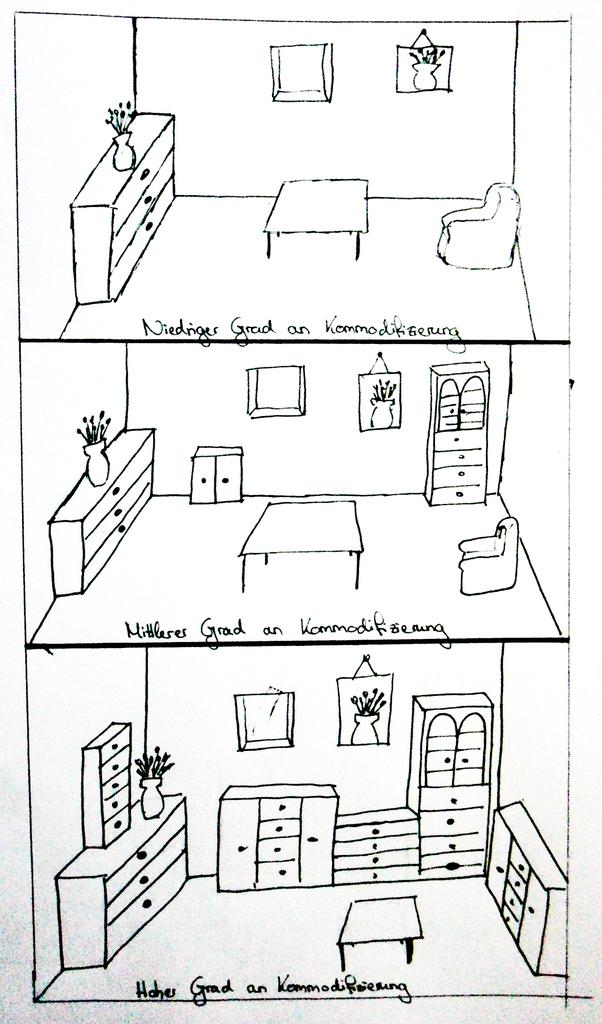What type of artwork is depicted in the image? The image is a collage. What are some of the sketched items in the collage? There is a sketch of a table, cupboards, and a flower vase in the image. Are there any other sketched items in the collage? Yes, there are other sketched items in the image. What can be found at the bottom side of the image? There is text at the bottom side of the image. What type of salt can be seen on the island in the image? There is no salt or island present in the image; it is a collage featuring sketched items and text. Is there a balloon visible in the image? There is no balloon present in the image. 